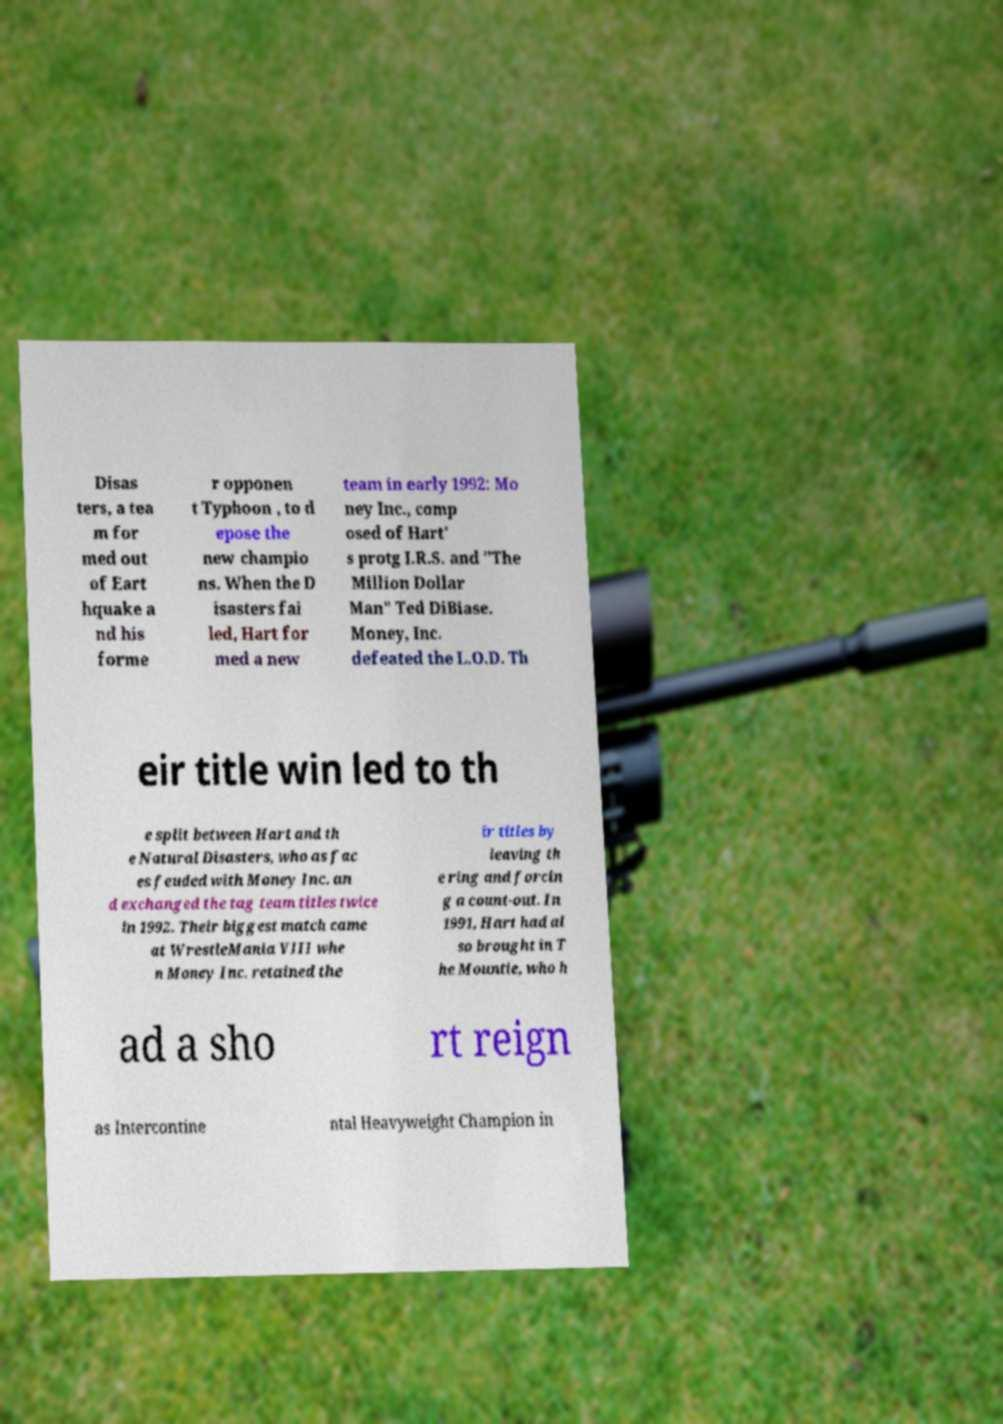There's text embedded in this image that I need extracted. Can you transcribe it verbatim? Disas ters, a tea m for med out of Eart hquake a nd his forme r opponen t Typhoon , to d epose the new champio ns. When the D isasters fai led, Hart for med a new team in early 1992: Mo ney Inc., comp osed of Hart' s protg I.R.S. and "The Million Dollar Man" Ted DiBiase. Money, Inc. defeated the L.O.D. Th eir title win led to th e split between Hart and th e Natural Disasters, who as fac es feuded with Money Inc. an d exchanged the tag team titles twice in 1992. Their biggest match came at WrestleMania VIII whe n Money Inc. retained the ir titles by leaving th e ring and forcin g a count-out. In 1991, Hart had al so brought in T he Mountie, who h ad a sho rt reign as Intercontine ntal Heavyweight Champion in 